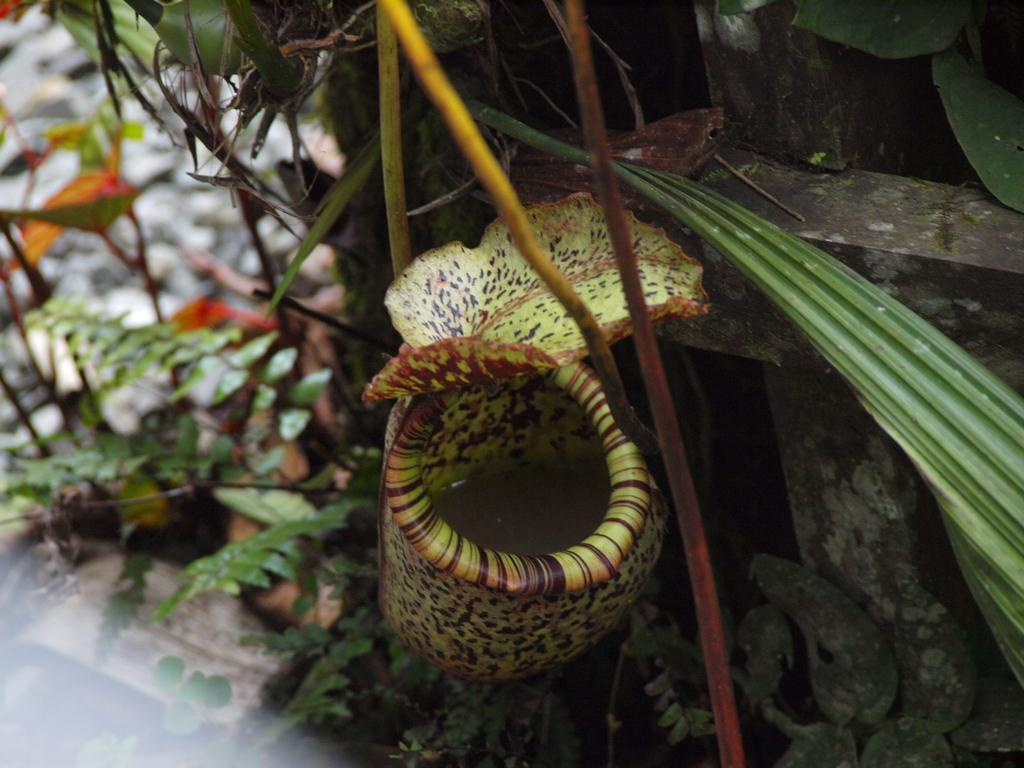Could you give a brief overview of what you see in this image? In this image, we can see plants, leaves and there is wood. At the bottom, there is a floor. 